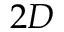<formula> <loc_0><loc_0><loc_500><loc_500>2 D</formula> 